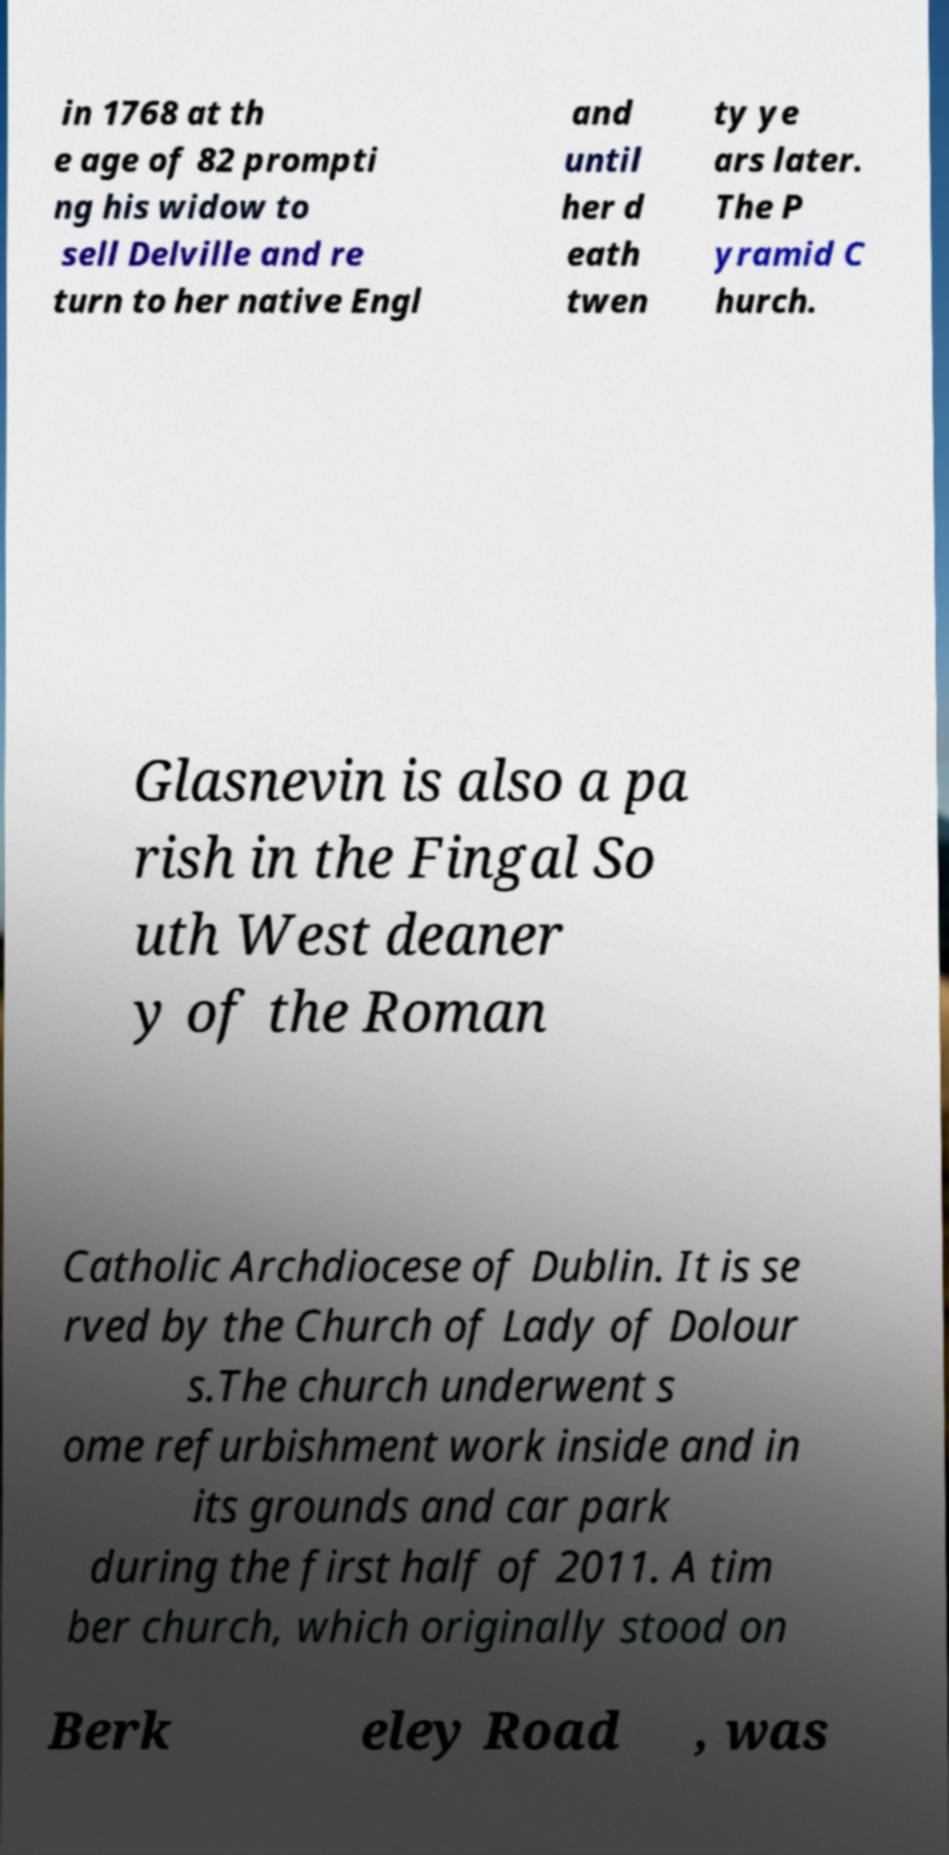Can you accurately transcribe the text from the provided image for me? in 1768 at th e age of 82 prompti ng his widow to sell Delville and re turn to her native Engl and until her d eath twen ty ye ars later. The P yramid C hurch. Glasnevin is also a pa rish in the Fingal So uth West deaner y of the Roman Catholic Archdiocese of Dublin. It is se rved by the Church of Lady of Dolour s.The church underwent s ome refurbishment work inside and in its grounds and car park during the first half of 2011. A tim ber church, which originally stood on Berk eley Road , was 